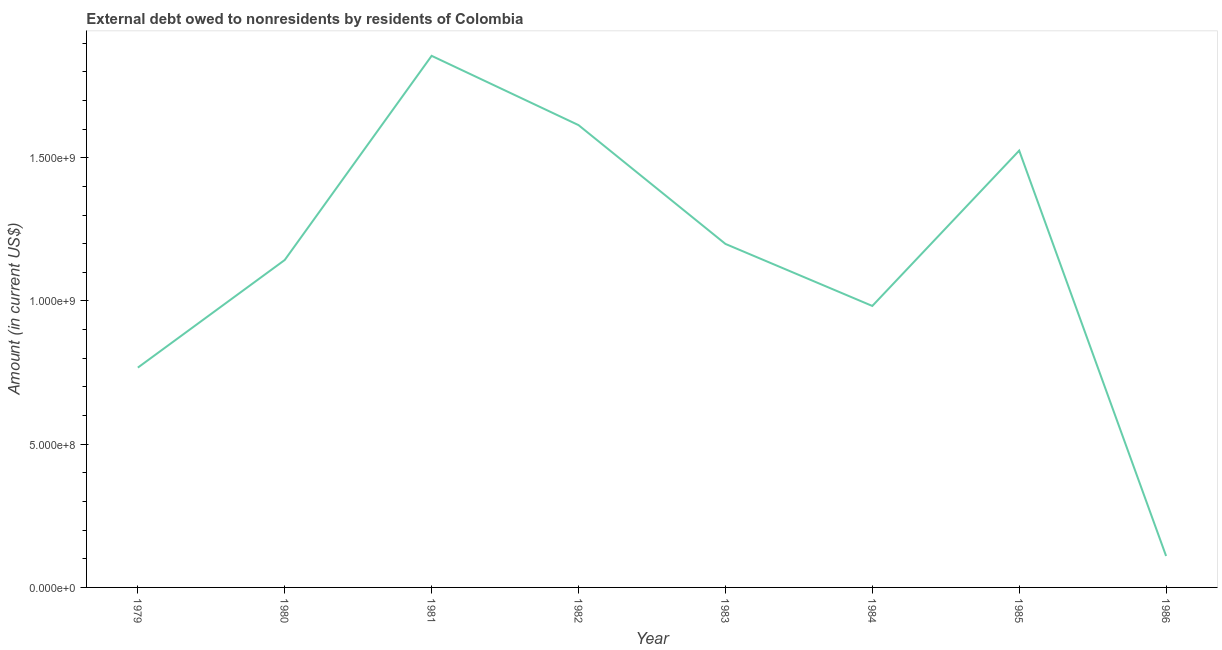What is the debt in 1986?
Provide a succinct answer. 1.10e+08. Across all years, what is the maximum debt?
Your answer should be very brief. 1.86e+09. Across all years, what is the minimum debt?
Your answer should be compact. 1.10e+08. In which year was the debt maximum?
Offer a terse response. 1981. In which year was the debt minimum?
Ensure brevity in your answer.  1986. What is the sum of the debt?
Provide a succinct answer. 9.20e+09. What is the difference between the debt in 1984 and 1986?
Your answer should be very brief. 8.73e+08. What is the average debt per year?
Ensure brevity in your answer.  1.15e+09. What is the median debt?
Keep it short and to the point. 1.17e+09. What is the ratio of the debt in 1981 to that in 1982?
Offer a very short reply. 1.15. Is the debt in 1980 less than that in 1981?
Give a very brief answer. Yes. Is the difference between the debt in 1980 and 1984 greater than the difference between any two years?
Your answer should be compact. No. What is the difference between the highest and the second highest debt?
Your answer should be compact. 2.42e+08. Is the sum of the debt in 1982 and 1984 greater than the maximum debt across all years?
Ensure brevity in your answer.  Yes. What is the difference between the highest and the lowest debt?
Ensure brevity in your answer.  1.75e+09. Does the debt monotonically increase over the years?
Your answer should be compact. No. What is the difference between two consecutive major ticks on the Y-axis?
Offer a terse response. 5.00e+08. Are the values on the major ticks of Y-axis written in scientific E-notation?
Offer a very short reply. Yes. Does the graph contain any zero values?
Your answer should be compact. No. Does the graph contain grids?
Your answer should be very brief. No. What is the title of the graph?
Give a very brief answer. External debt owed to nonresidents by residents of Colombia. What is the label or title of the Y-axis?
Your response must be concise. Amount (in current US$). What is the Amount (in current US$) of 1979?
Your response must be concise. 7.67e+08. What is the Amount (in current US$) of 1980?
Offer a very short reply. 1.14e+09. What is the Amount (in current US$) of 1981?
Offer a very short reply. 1.86e+09. What is the Amount (in current US$) in 1982?
Offer a very short reply. 1.61e+09. What is the Amount (in current US$) of 1983?
Your response must be concise. 1.20e+09. What is the Amount (in current US$) in 1984?
Your response must be concise. 9.83e+08. What is the Amount (in current US$) in 1985?
Your response must be concise. 1.53e+09. What is the Amount (in current US$) in 1986?
Your answer should be very brief. 1.10e+08. What is the difference between the Amount (in current US$) in 1979 and 1980?
Provide a short and direct response. -3.76e+08. What is the difference between the Amount (in current US$) in 1979 and 1981?
Offer a very short reply. -1.09e+09. What is the difference between the Amount (in current US$) in 1979 and 1982?
Provide a succinct answer. -8.47e+08. What is the difference between the Amount (in current US$) in 1979 and 1983?
Give a very brief answer. -4.32e+08. What is the difference between the Amount (in current US$) in 1979 and 1984?
Offer a very short reply. -2.15e+08. What is the difference between the Amount (in current US$) in 1979 and 1985?
Provide a short and direct response. -7.58e+08. What is the difference between the Amount (in current US$) in 1979 and 1986?
Give a very brief answer. 6.58e+08. What is the difference between the Amount (in current US$) in 1980 and 1981?
Your answer should be compact. -7.13e+08. What is the difference between the Amount (in current US$) in 1980 and 1982?
Offer a terse response. -4.71e+08. What is the difference between the Amount (in current US$) in 1980 and 1983?
Your answer should be compact. -5.62e+07. What is the difference between the Amount (in current US$) in 1980 and 1984?
Ensure brevity in your answer.  1.60e+08. What is the difference between the Amount (in current US$) in 1980 and 1985?
Your response must be concise. -3.82e+08. What is the difference between the Amount (in current US$) in 1980 and 1986?
Your answer should be very brief. 1.03e+09. What is the difference between the Amount (in current US$) in 1981 and 1982?
Give a very brief answer. 2.42e+08. What is the difference between the Amount (in current US$) in 1981 and 1983?
Ensure brevity in your answer.  6.57e+08. What is the difference between the Amount (in current US$) in 1981 and 1984?
Provide a succinct answer. 8.73e+08. What is the difference between the Amount (in current US$) in 1981 and 1985?
Your response must be concise. 3.31e+08. What is the difference between the Amount (in current US$) in 1981 and 1986?
Keep it short and to the point. 1.75e+09. What is the difference between the Amount (in current US$) in 1982 and 1983?
Provide a succinct answer. 4.15e+08. What is the difference between the Amount (in current US$) in 1982 and 1984?
Provide a short and direct response. 6.31e+08. What is the difference between the Amount (in current US$) in 1982 and 1985?
Offer a very short reply. 8.90e+07. What is the difference between the Amount (in current US$) in 1982 and 1986?
Provide a short and direct response. 1.50e+09. What is the difference between the Amount (in current US$) in 1983 and 1984?
Provide a succinct answer. 2.17e+08. What is the difference between the Amount (in current US$) in 1983 and 1985?
Make the answer very short. -3.26e+08. What is the difference between the Amount (in current US$) in 1983 and 1986?
Provide a short and direct response. 1.09e+09. What is the difference between the Amount (in current US$) in 1984 and 1985?
Your answer should be compact. -5.42e+08. What is the difference between the Amount (in current US$) in 1984 and 1986?
Ensure brevity in your answer.  8.73e+08. What is the difference between the Amount (in current US$) in 1985 and 1986?
Provide a short and direct response. 1.42e+09. What is the ratio of the Amount (in current US$) in 1979 to that in 1980?
Provide a short and direct response. 0.67. What is the ratio of the Amount (in current US$) in 1979 to that in 1981?
Your response must be concise. 0.41. What is the ratio of the Amount (in current US$) in 1979 to that in 1982?
Give a very brief answer. 0.47. What is the ratio of the Amount (in current US$) in 1979 to that in 1983?
Offer a terse response. 0.64. What is the ratio of the Amount (in current US$) in 1979 to that in 1984?
Your response must be concise. 0.78. What is the ratio of the Amount (in current US$) in 1979 to that in 1985?
Your answer should be very brief. 0.5. What is the ratio of the Amount (in current US$) in 1979 to that in 1986?
Offer a terse response. 6.99. What is the ratio of the Amount (in current US$) in 1980 to that in 1981?
Keep it short and to the point. 0.62. What is the ratio of the Amount (in current US$) in 1980 to that in 1982?
Provide a short and direct response. 0.71. What is the ratio of the Amount (in current US$) in 1980 to that in 1983?
Offer a terse response. 0.95. What is the ratio of the Amount (in current US$) in 1980 to that in 1984?
Make the answer very short. 1.16. What is the ratio of the Amount (in current US$) in 1980 to that in 1985?
Give a very brief answer. 0.75. What is the ratio of the Amount (in current US$) in 1980 to that in 1986?
Give a very brief answer. 10.42. What is the ratio of the Amount (in current US$) in 1981 to that in 1982?
Your answer should be compact. 1.15. What is the ratio of the Amount (in current US$) in 1981 to that in 1983?
Keep it short and to the point. 1.55. What is the ratio of the Amount (in current US$) in 1981 to that in 1984?
Offer a very short reply. 1.89. What is the ratio of the Amount (in current US$) in 1981 to that in 1985?
Ensure brevity in your answer.  1.22. What is the ratio of the Amount (in current US$) in 1981 to that in 1986?
Provide a succinct answer. 16.91. What is the ratio of the Amount (in current US$) in 1982 to that in 1983?
Your response must be concise. 1.35. What is the ratio of the Amount (in current US$) in 1982 to that in 1984?
Ensure brevity in your answer.  1.64. What is the ratio of the Amount (in current US$) in 1982 to that in 1985?
Your answer should be compact. 1.06. What is the ratio of the Amount (in current US$) in 1982 to that in 1986?
Your response must be concise. 14.71. What is the ratio of the Amount (in current US$) in 1983 to that in 1984?
Provide a succinct answer. 1.22. What is the ratio of the Amount (in current US$) in 1983 to that in 1985?
Ensure brevity in your answer.  0.79. What is the ratio of the Amount (in current US$) in 1983 to that in 1986?
Keep it short and to the point. 10.93. What is the ratio of the Amount (in current US$) in 1984 to that in 1985?
Provide a succinct answer. 0.64. What is the ratio of the Amount (in current US$) in 1984 to that in 1986?
Offer a terse response. 8.95. What is the ratio of the Amount (in current US$) in 1985 to that in 1986?
Ensure brevity in your answer.  13.9. 